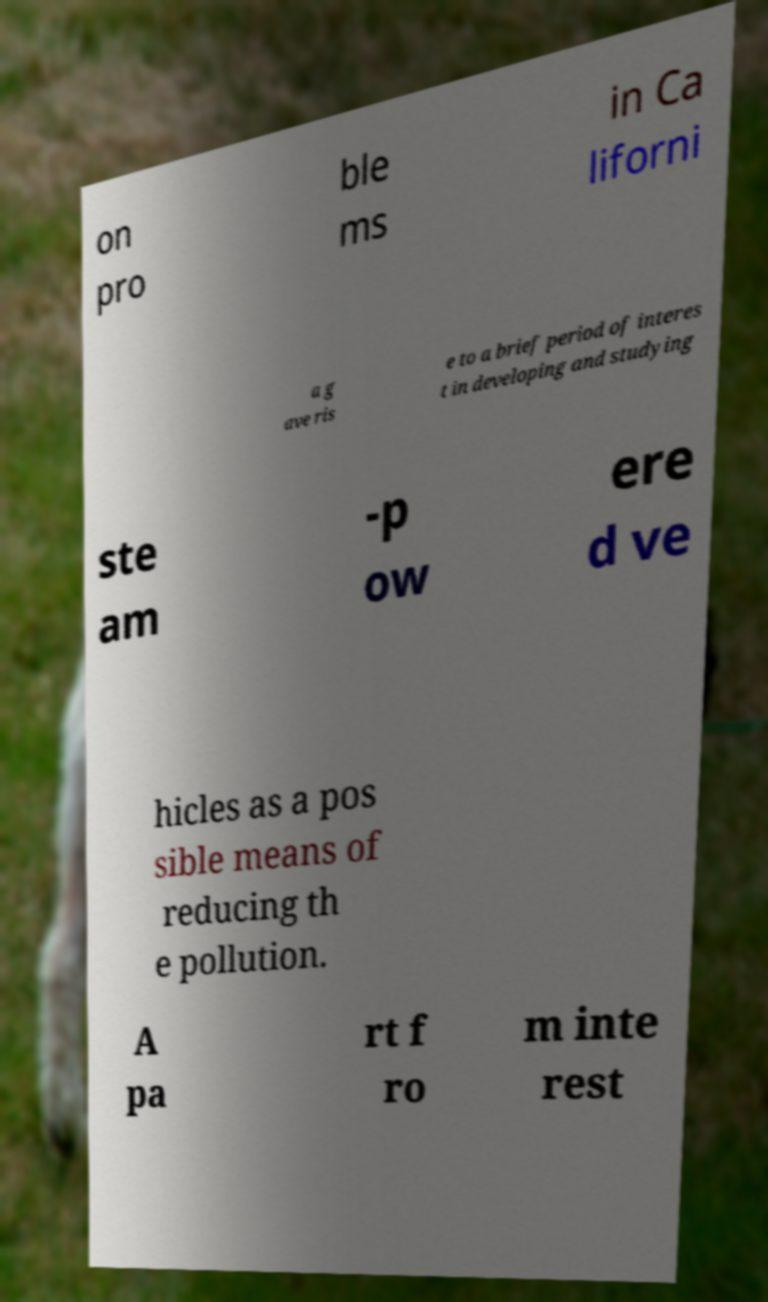Can you read and provide the text displayed in the image?This photo seems to have some interesting text. Can you extract and type it out for me? on pro ble ms in Ca liforni a g ave ris e to a brief period of interes t in developing and studying ste am -p ow ere d ve hicles as a pos sible means of reducing th e pollution. A pa rt f ro m inte rest 